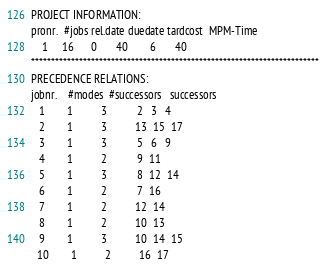Convert code to text. <code><loc_0><loc_0><loc_500><loc_500><_ObjectiveC_>PROJECT INFORMATION:
pronr.  #jobs rel.date duedate tardcost  MPM-Time
    1     16      0       40        6       40
************************************************************************
PRECEDENCE RELATIONS:
jobnr.    #modes  #successors   successors
   1        1          3           2   3   4
   2        1          3          13  15  17
   3        1          3           5   6   9
   4        1          2           9  11
   5        1          3           8  12  14
   6        1          2           7  16
   7        1          2          12  14
   8        1          2          10  13
   9        1          3          10  14  15
  10        1          2          16  17</code> 